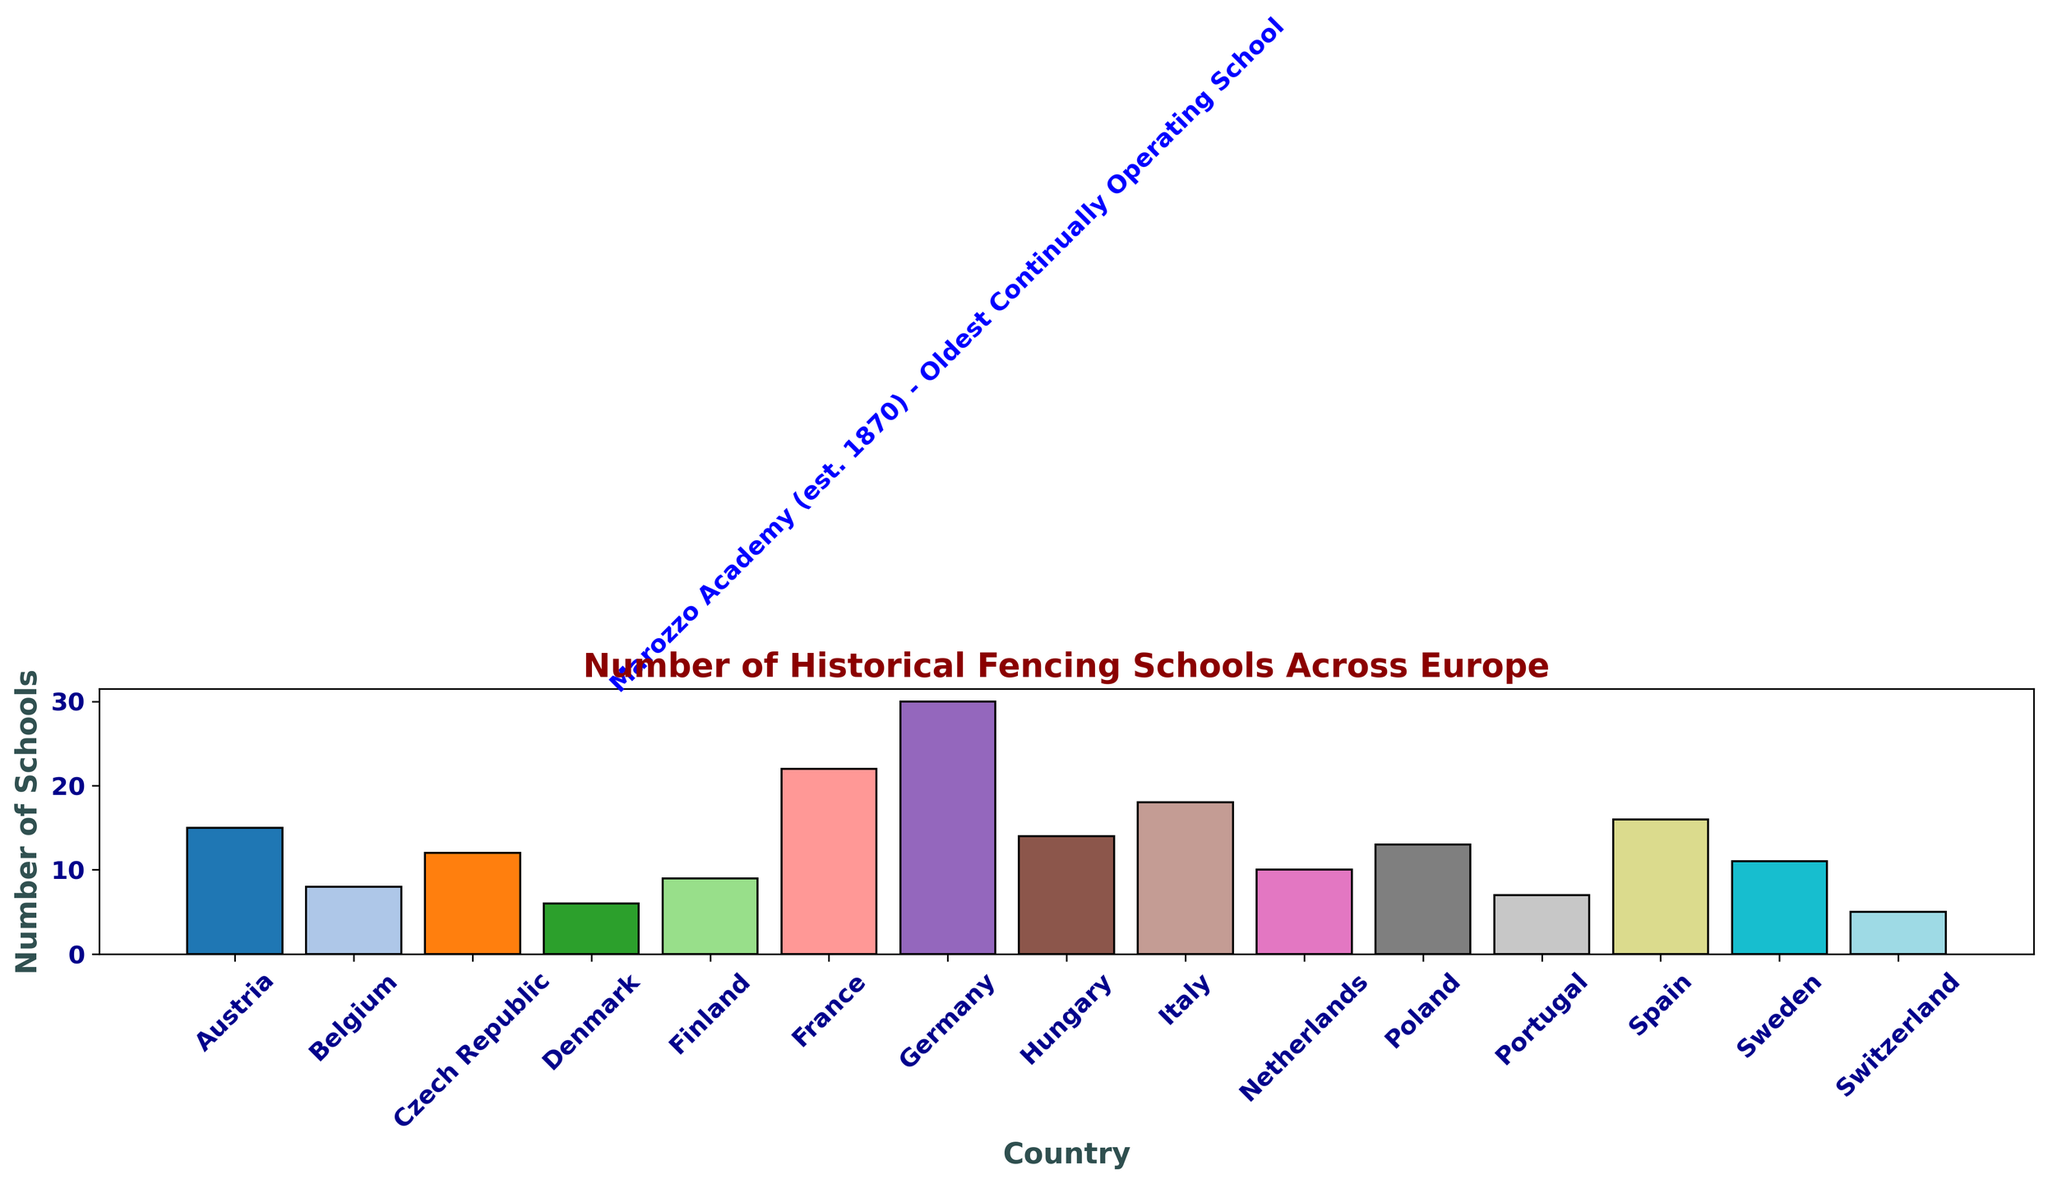Which country has the highest number of historical fencing schools? By looking at the bar chart, Germany has the tallest bar which indicates the highest number of historical fencing schools.
Answer: Germany What is the total number of historical fencing schools in France, Spain, and Italy? France has 22 schools, Spain has 16 schools, and Italy has 18 schools. Adding them together: 22 + 16 + 18 = 56.
Answer: 56 Which country has fewer historical fencing schools: Finland or Belgium? By comparing the heights of the bars, Finland has 9 schools and Belgium has 8 schools. Therefore, Belgium has fewer.
Answer: Belgium How many more historical fencing schools does Germany have compared to Switzerland? Germany has 30 schools, and Switzerland has 5 schools. The difference is 30 - 5 = 25.
Answer: 25 Which countries have a number of historical fencing schools between 10 and 15? The bars representing Czech Republic (12), Netherlands (10), Sweden (11), Austria (15), Hungary (14), and Poland (13) fall between 10 and 15.
Answer: Czech Republic, Netherlands, Sweden, Austria, Hungary, Poland What is the average number of historical fencing schools in Austria, Poland, and Switzerland? Austria has 15 schools, Poland has 13 schools, and Switzerland has 5 schools. The average is (15 + 13 + 5) / 3 = 33 / 3 = 11.
Answer: 11 What is the note associated with Germany on the chart? The note added to Germany’s bar indicates that it is home to the Marozzo Academy, the oldest continually operating school, established in 1870.
Answer: Marozzo Academy (est. 1870) - Oldest Continually Operating School 